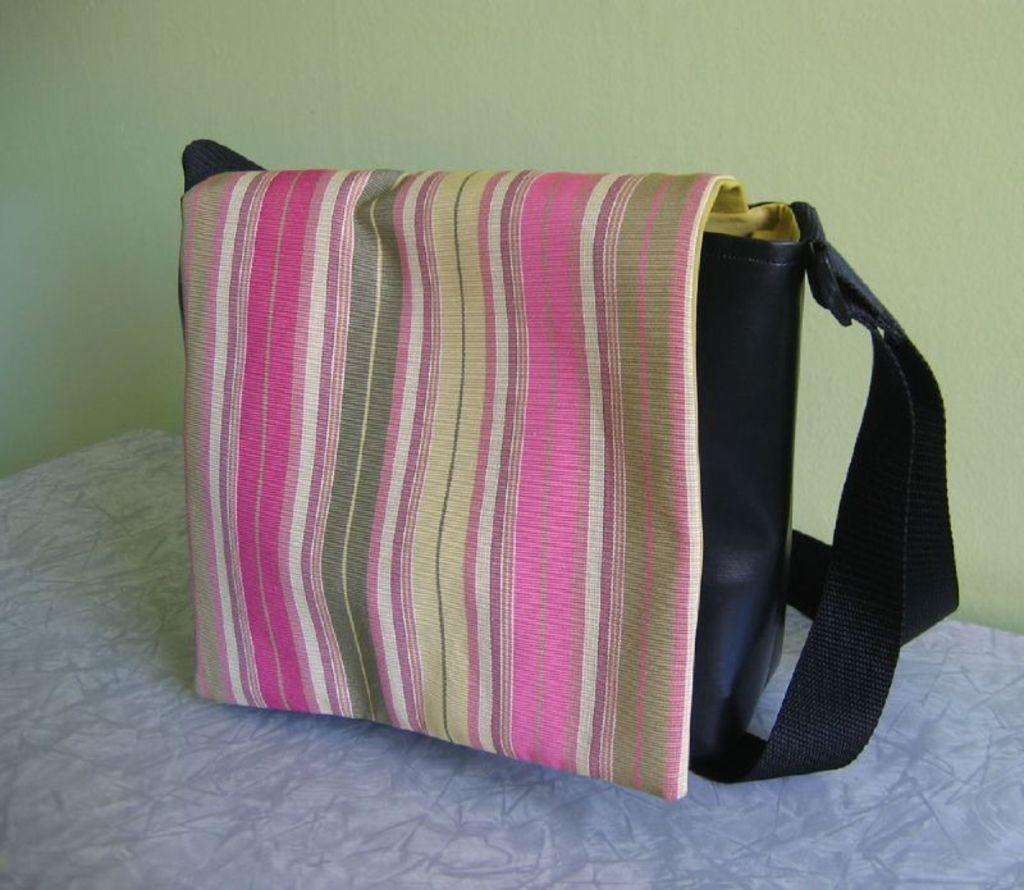What object is present in the image that can be used for carrying items? There is a bag in the image that can be used for carrying items. How is the front of the bag designed? The front of the bag has a multi-colored design. What color is the back of the bag? The back of the bag is black. Where is the bag located in the image? The bag is placed on a table. In which direction is the grain growing in the image? There is no grain present in the image, so it is not possible to determine the direction of its growth. 